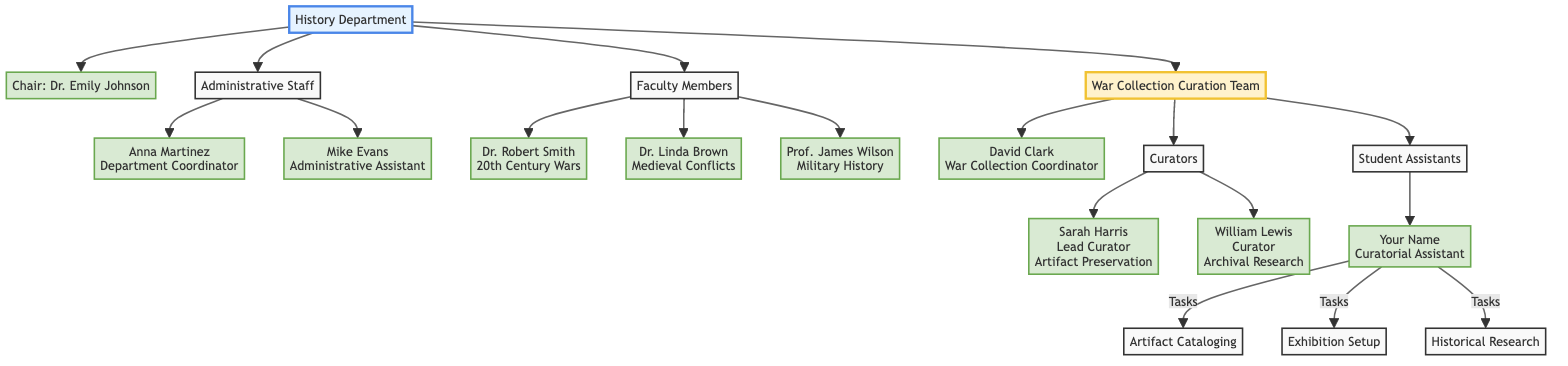What is the name of the chair of the History Department? The diagram clearly states the name of the chair is Dr. Emily Johnson, indicated directly under the "Chair" node, which is connected to the "History Department" node.
Answer: Dr. Emily Johnson How many faculty members are listed in the diagram? By examining the "Faculty Members" section of the diagram, there are three names listed: Dr. Robert Smith, Dr. Linda Brown, and Prof. James Wilson, which total to three faculty members.
Answer: 3 Who is the Lead Curator in the War Collection Curation Team? The diagram identifies the Lead Curator under the "Curators" node, where Sarah Harris is explicitly mentioned as the individual holding that role.
Answer: Sarah Harris What role does Anna Martinez fulfill in the History Department? According to the diagram, Anna Martinez is depicted under the "Administrative Staff" node with the role of "Department Coordinator," clearly labeling her function within the department.
Answer: Department Coordinator Which specialization does Dr. Robert Smith focus on? From the "Faculty Members" section of the diagram, it is noted that Dr. Robert Smith specializes in "20th Century Wars," which is specified alongside his name.
Answer: 20th Century Wars Who oversees the War Collection Curation Team? The diagram points to David Clark as the War Collection Coordinator under the "War Collection Curation Team" node, signifying his oversight role within that team.
Answer: David Clark What tasks are assigned to the Student Assistant? The diagram lists three tasks directly connected to "Your Name" under the "Student Assistants" node: "Artifact Cataloging," "Exhibition Setup," and "Historical Research."
Answer: Artifact Cataloging, Exhibition Setup, Historical Research How many curators are part of the War Collection Curation Team? The diagram shows that there are two individuals listed as curators: Sarah Harris and William Lewis, hence the count totals to two curators within the team.
Answer: 2 What is the role of Mike Evans in the History Department? According to the diagram, Mike Evans is identified under the "Administrative Staff" node as the "Administrative Assistant," indicating his position within the department.
Answer: Administrative Assistant 